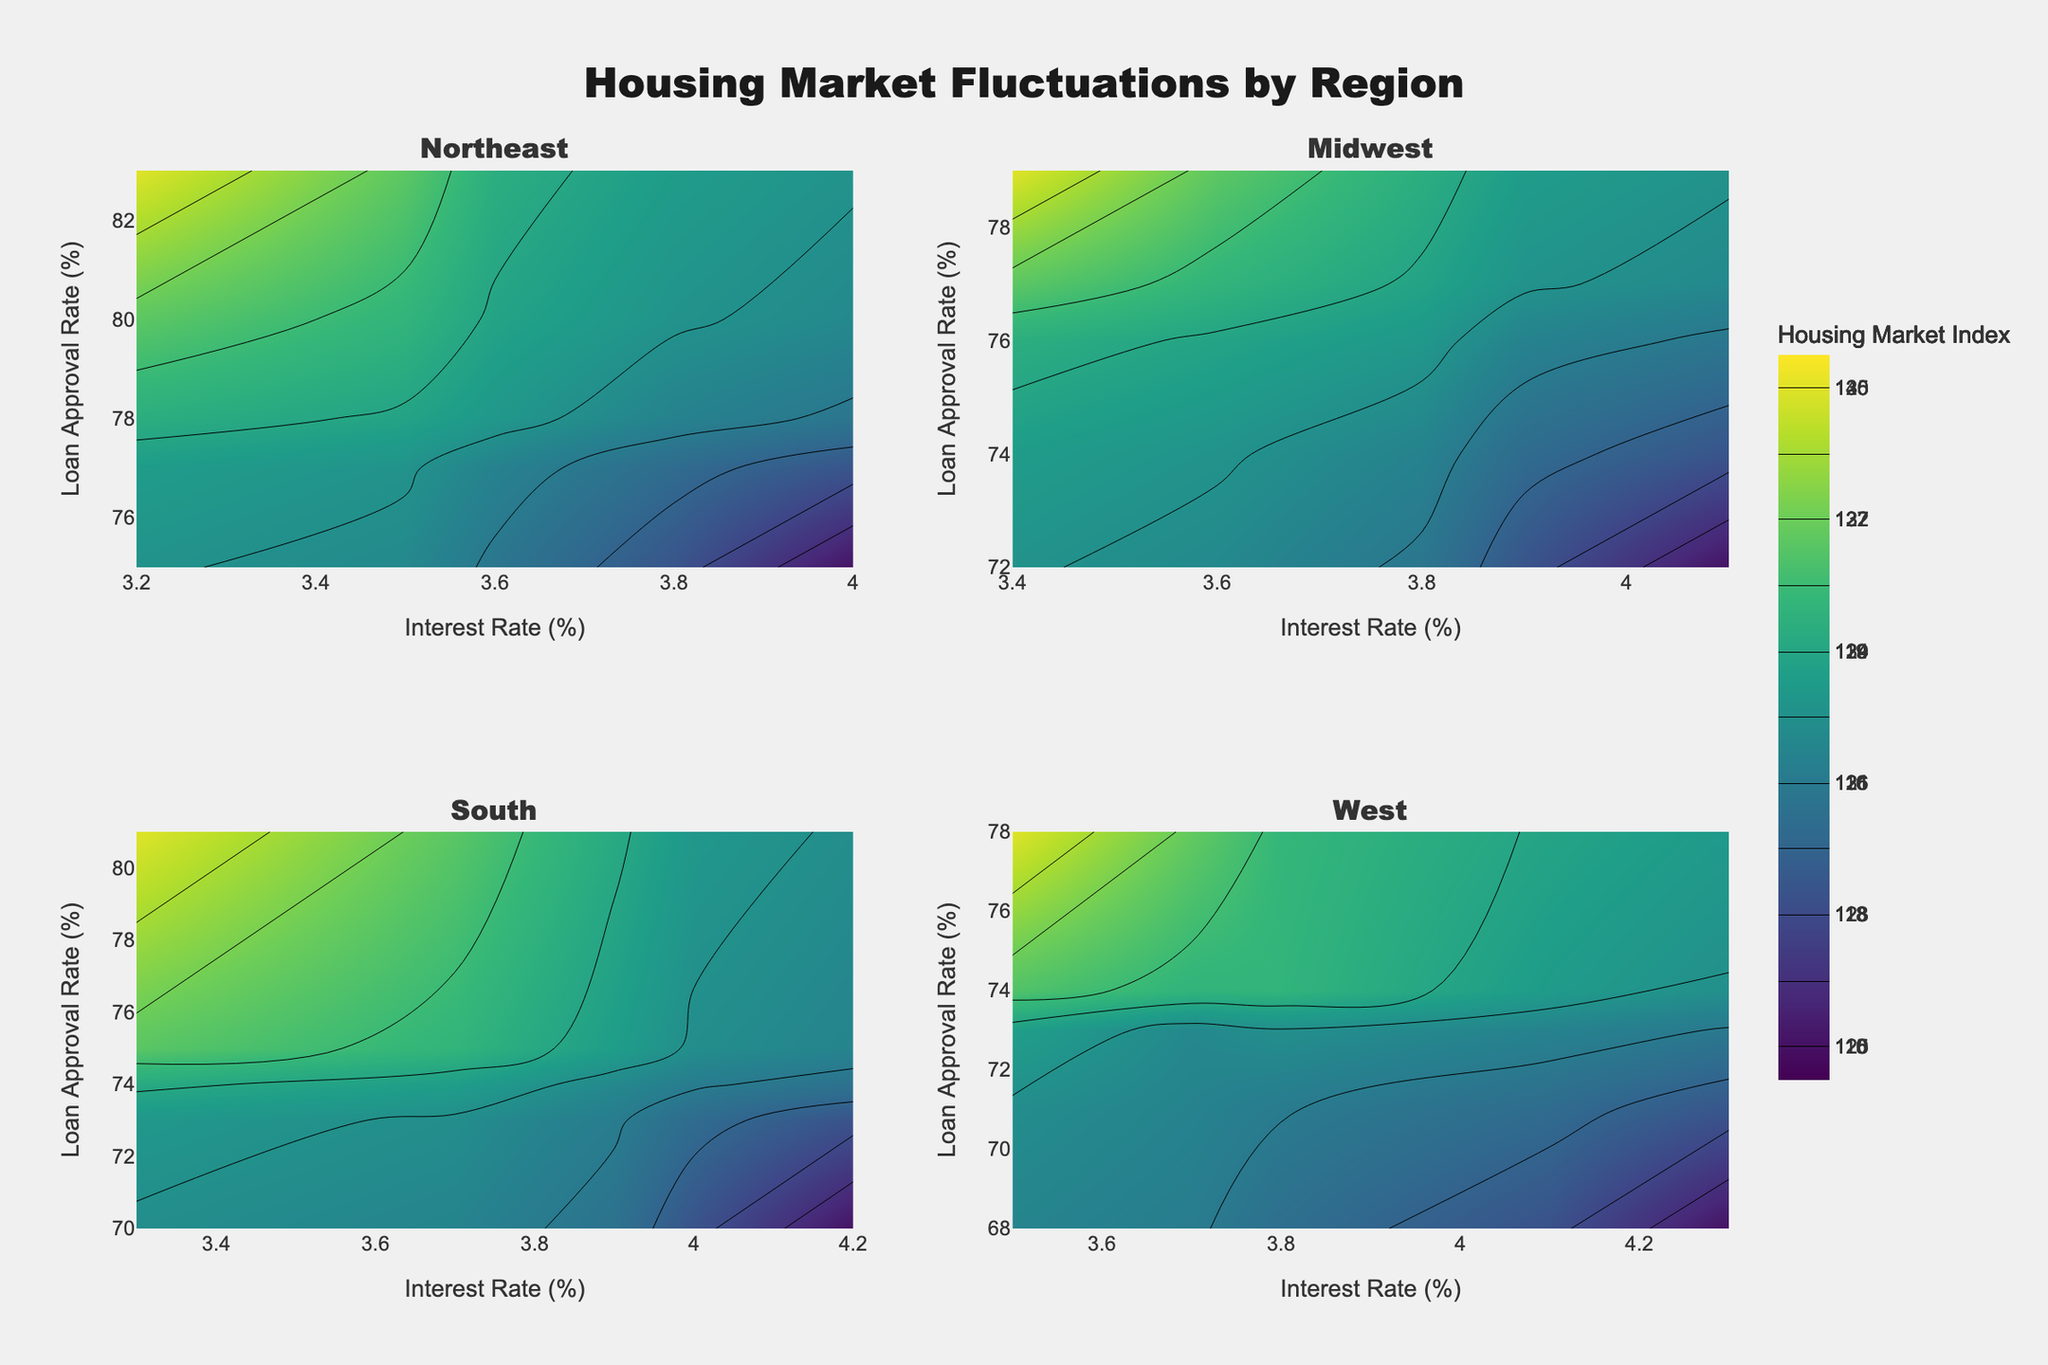What's the title of the figure? The title is displayed at the top center of the figure. It is a short text summarizing the content of the figure.
Answer: Housing Market Fluctuations by Region Which region has the highest Housing Market Index for 2021? By examining the contour plots, find the highest value of the Housing Market Index for each region in 2021. Look at the region with the highest index.
Answer: West What is the color scale used in the figure for representing the Housing Market Index? The color scale is usually indicated by the legend or color bar near the figure, with a title typically saying "Housing Market Index." The specific colors identify the range of values.
Answer: Viridis What's the trend in the Housing Market Index in the Midwest from 2018 to 2022? Following the contour lines in the Midwest subplot, track the Housing Market Index values over these years. Look for any upward, downward, or stable trend.
Answer: Generally increasing, then slightly decreasing in 2022 Which region shows the greatest fluctuation in Interest Rates over the years? Compare the range of Interest Rates across the years for each region by looking at the x-axis of each subplot. Identify which region has the greatest difference between its maximum and minimum Interest Rates.
Answer: West What's the relationship between the Loan Approval Rate and the Housing Market Index in the South? Look at the South subplot and examine if there's a pattern or correlation between the Loan Approval Rate (y-axis) and the Housing Market Index (contour values). Determine if higher Loan Approval Rates correspond to higher Housing Market Index values.
Answer: Generally positive correlation In 2022, which region had the lowest Housing Market Index? By examining the contour lines and numerical data of each subplot for the year 2022, identify which region has the lowest Housing Market Index.
Answer: Midwest How does the Housing Market Index in the Northeast change with increasing Interest Rates? Observe the contour lines in the Northeast subplot. Note the changes in the Housing Market Index values as the Interest Rates (x-axis) increase.
Answer: Generally decreases Compare the peak Loan Approval Rate between the West and the Northeast. Look at the y-axis (Loan Approval Rate) in the West and Northeast subplots to identify the maximum rate achieved in both regions. Compare these two values.
Answer: Northeast's peak is higher 